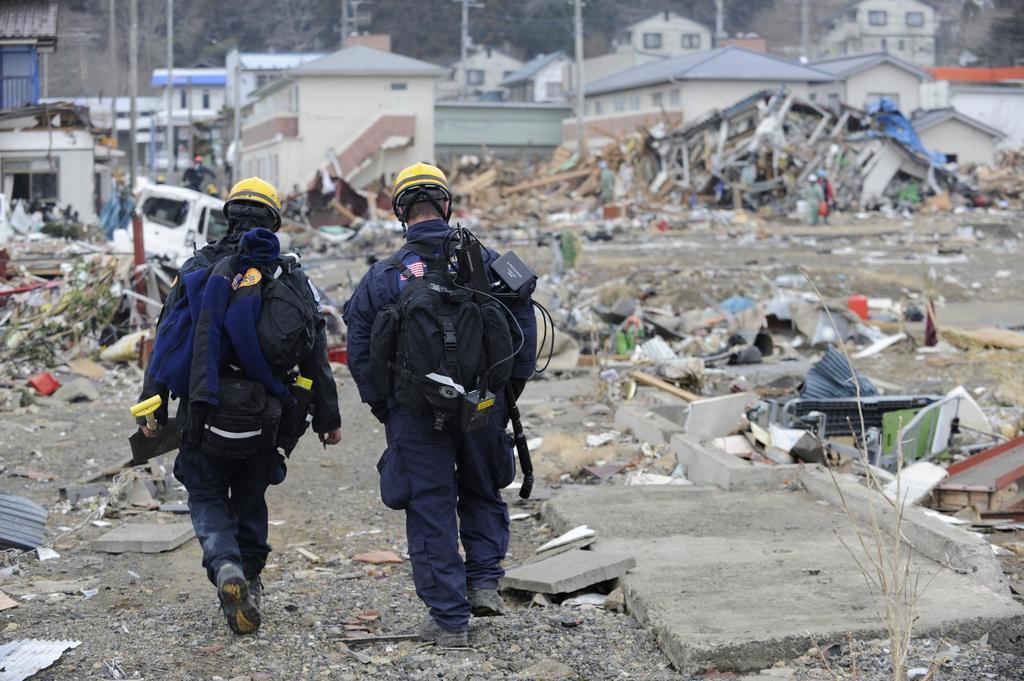Could you give a brief overview of what you see in this image? In the middle two persons are walking, they wore blue color coats, trousers and yellow color caps. At the back side there are houses in this image. 